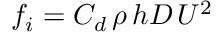<formula> <loc_0><loc_0><loc_500><loc_500>f _ { i } = C _ { d } \, \rho \, h D \, U ^ { 2 }</formula> 